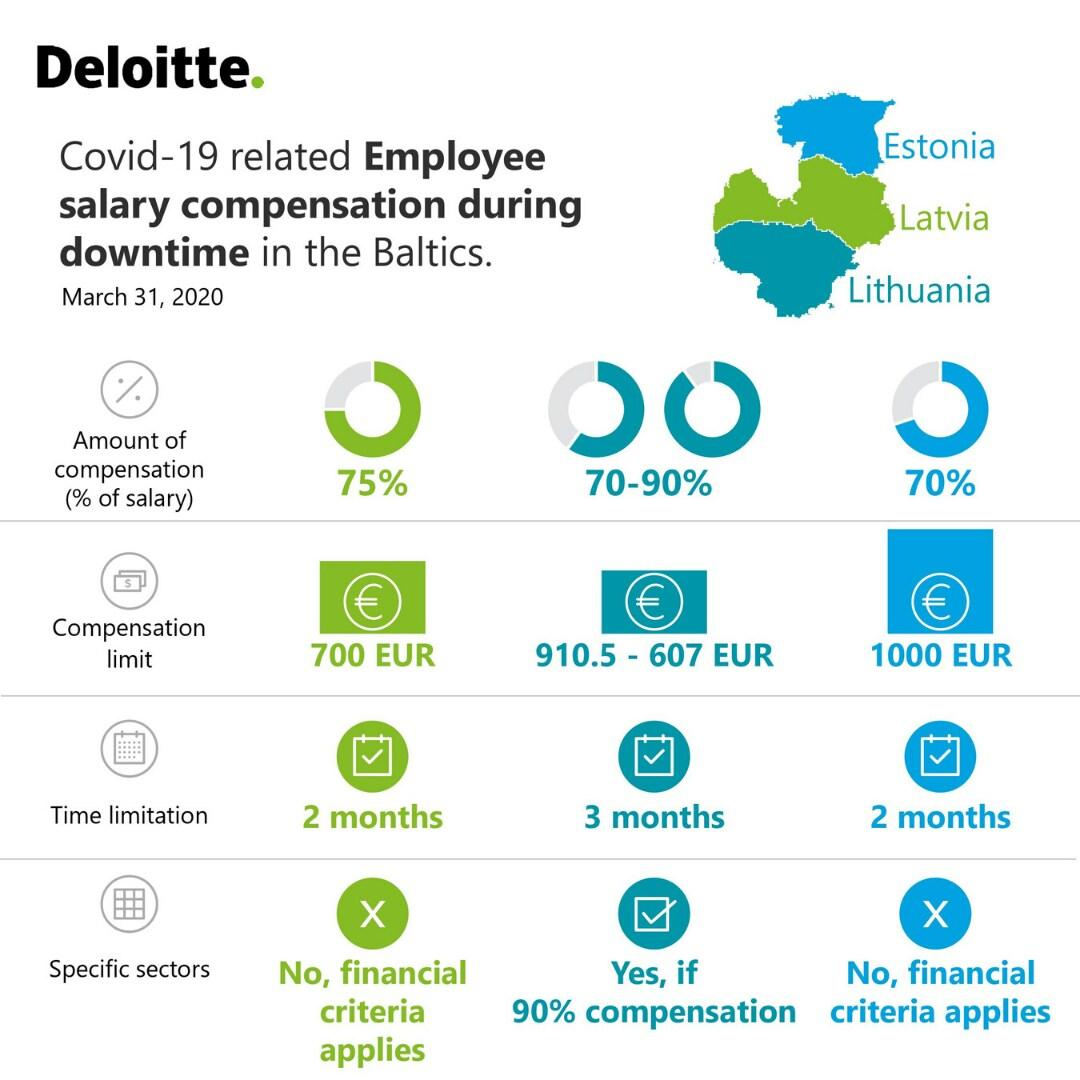Mention a couple of crucial points in this snapshot. As of March 31, 2020, no financial criteria were applied to specific sectors in the Baltic states of Latvia and Estonia. During the COVID-19 pandemic, employees in Estonia reported receiving a salary compensation of 70% as of March 31, 2020, as a result of the impact on businesses and the economy. According to a report, as of March 31, 2020, in Lithuania, the percentage of salary compensation offered to employees due to the impact of the COVID-19 pandemic ranged from 70 to 90%. As of March 31, 2020, there is a two-month time limit for Covid-19 related employee salary compensation in Latvia. According to data available as of March 31, 2020, a significant percentage of salary compensation offered to employees in Latvia was due to the impact of the COVID-19 pandemic. Specifically, 75% of salary compensation was affected by the pandemic. 